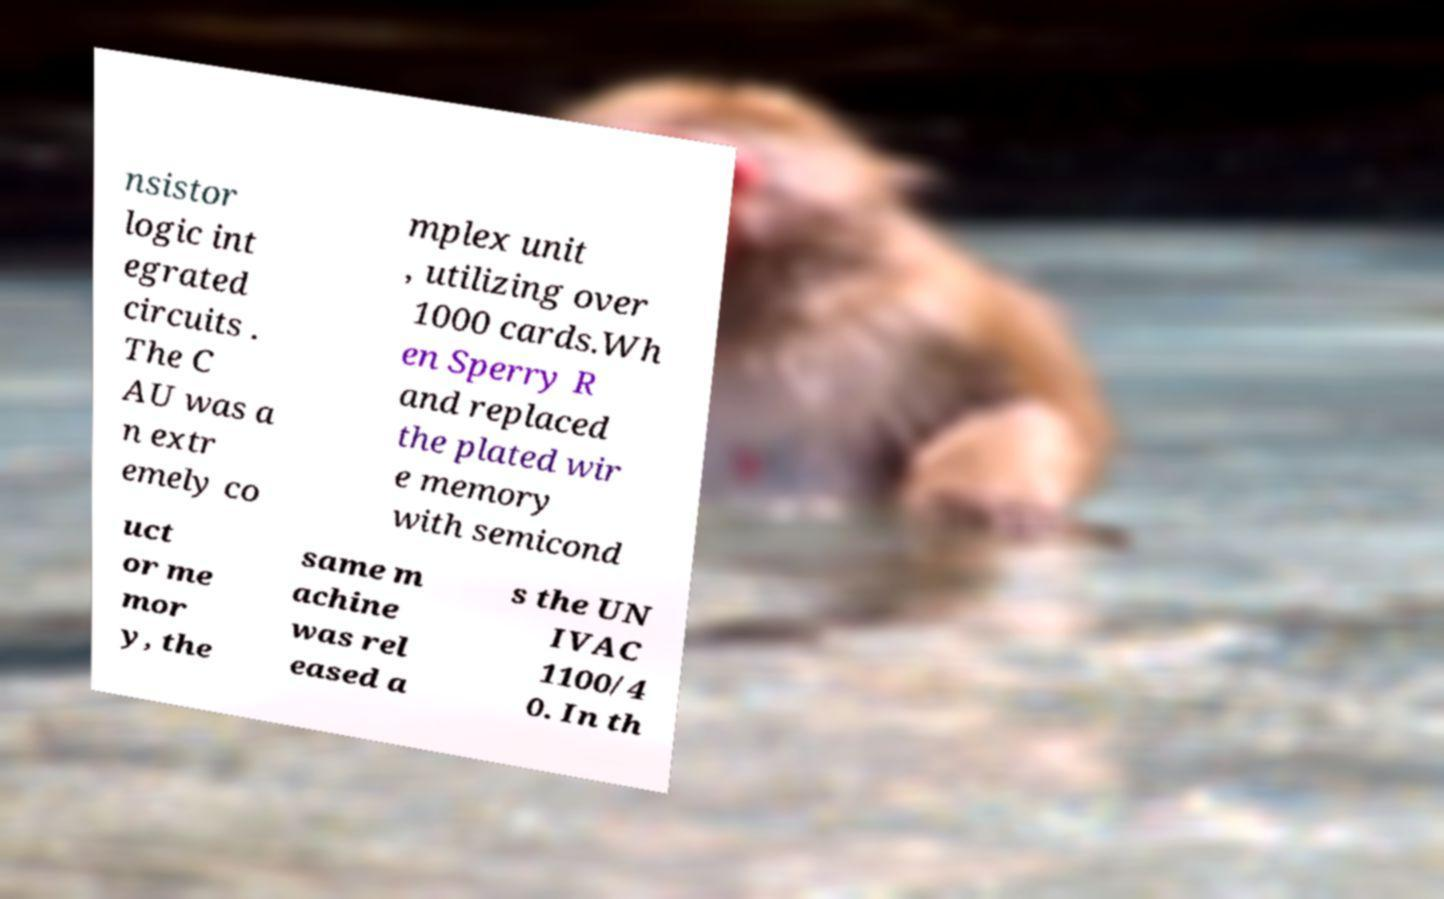For documentation purposes, I need the text within this image transcribed. Could you provide that? nsistor logic int egrated circuits . The C AU was a n extr emely co mplex unit , utilizing over 1000 cards.Wh en Sperry R and replaced the plated wir e memory with semicond uct or me mor y, the same m achine was rel eased a s the UN IVAC 1100/4 0. In th 